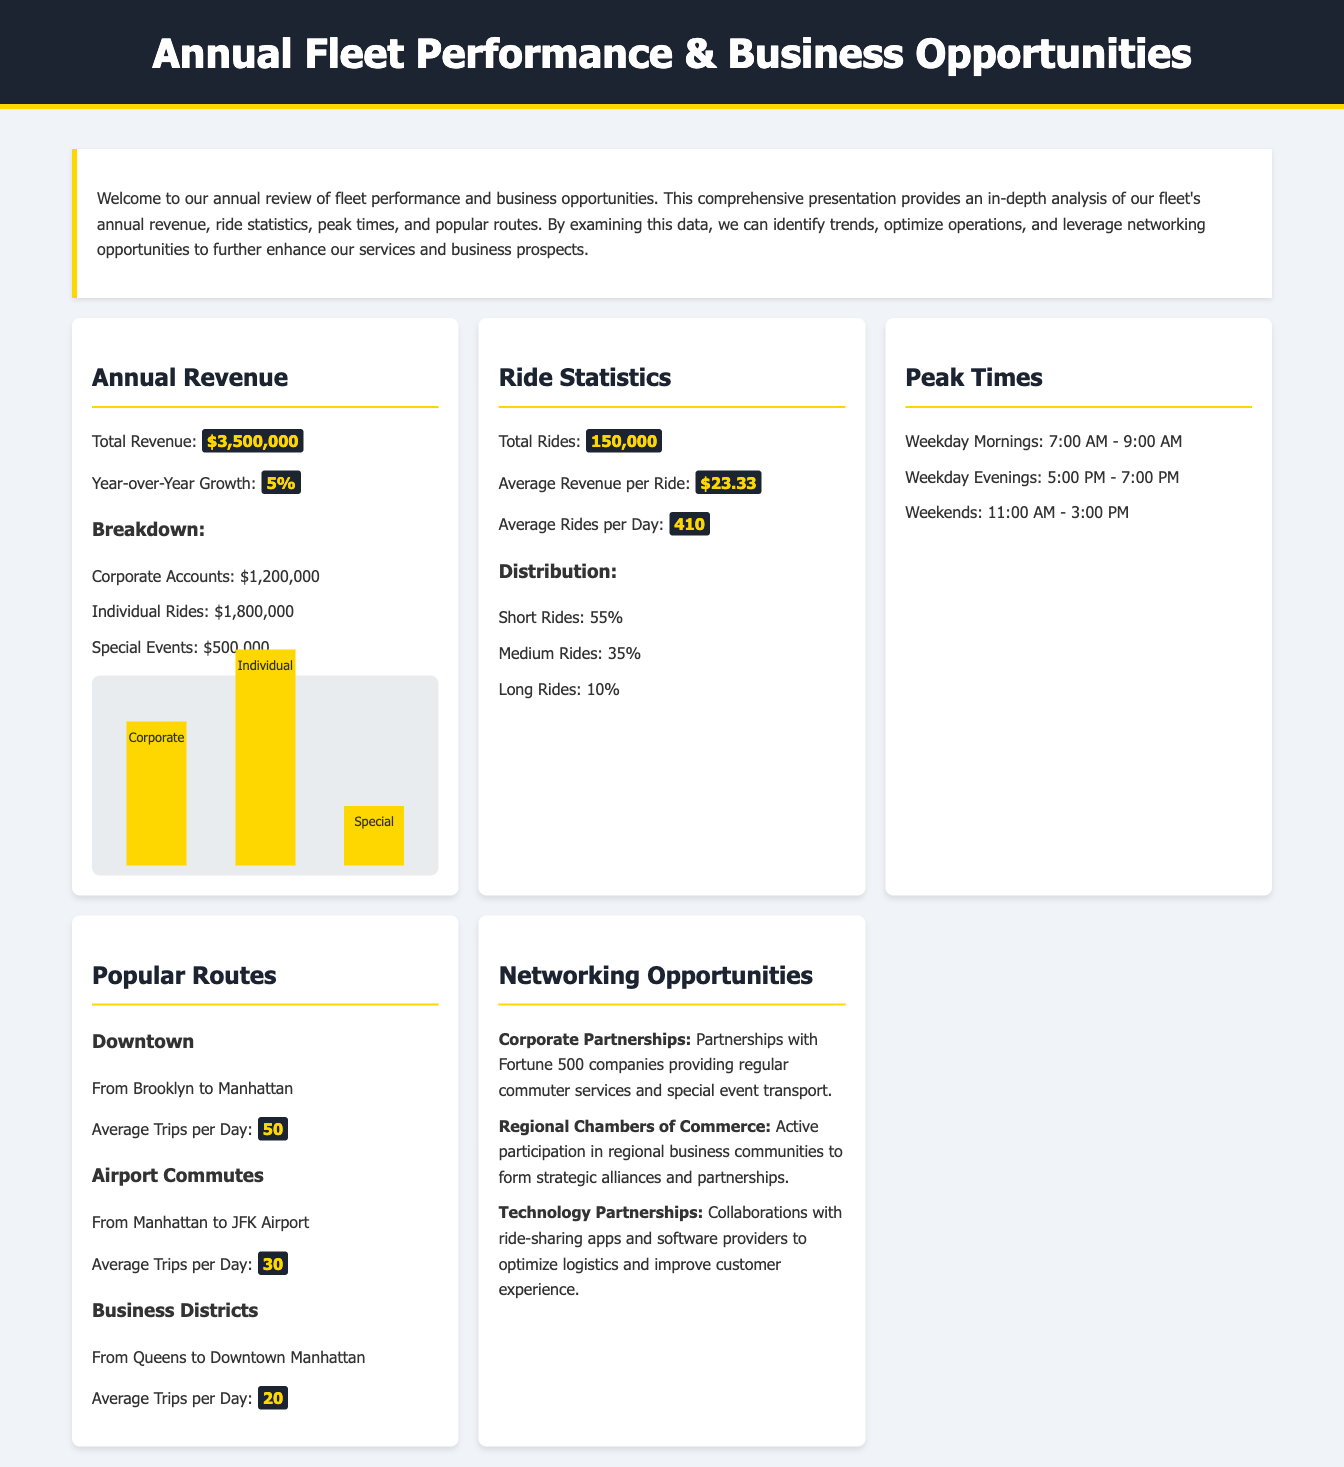What is the total revenue? The total revenue is highlighted in the "Annual Revenue" section as $3,500,000.
Answer: $3,500,000 What percentage is the year-over-year growth? The year-over-year growth is specified as 5% in the "Annual Revenue" section.
Answer: 5% How many total rides were there? The total rides is stated in the "Ride Statistics" section as 150,000.
Answer: 150,000 What is the average revenue per ride? The average revenue per ride is shown as $23.33 in the "Ride Statistics" section.
Answer: $23.33 What time frame is identified as peak times on weekdays? The peak times for weekdays are listed as 7:00 AM - 9:00 AM and 5:00 PM - 7:00 PM.
Answer: 7:00 AM - 9:00 AM and 5:00 PM - 7:00 PM From which locations does the popular Downtown route operate? The popular Downtown route operates from Brooklyn to Manhattan as described in the "Popular Routes" section.
Answer: Brooklyn to Manhattan How many average trips per day are made for Airport Commutes? The "Popular Routes" section states that Airport Commutes have an average of 30 trips per day.
Answer: 30 What type of partnerships are highlighted under Networking Opportunities? The document mentions Corporate Partnerships as one of the highlighted types of partnerships.
Answer: Corporate Partnerships What percentage of rides are classified as short rides? The percentage of short rides in the "Ride Statistics" section is 55%.
Answer: 55% 